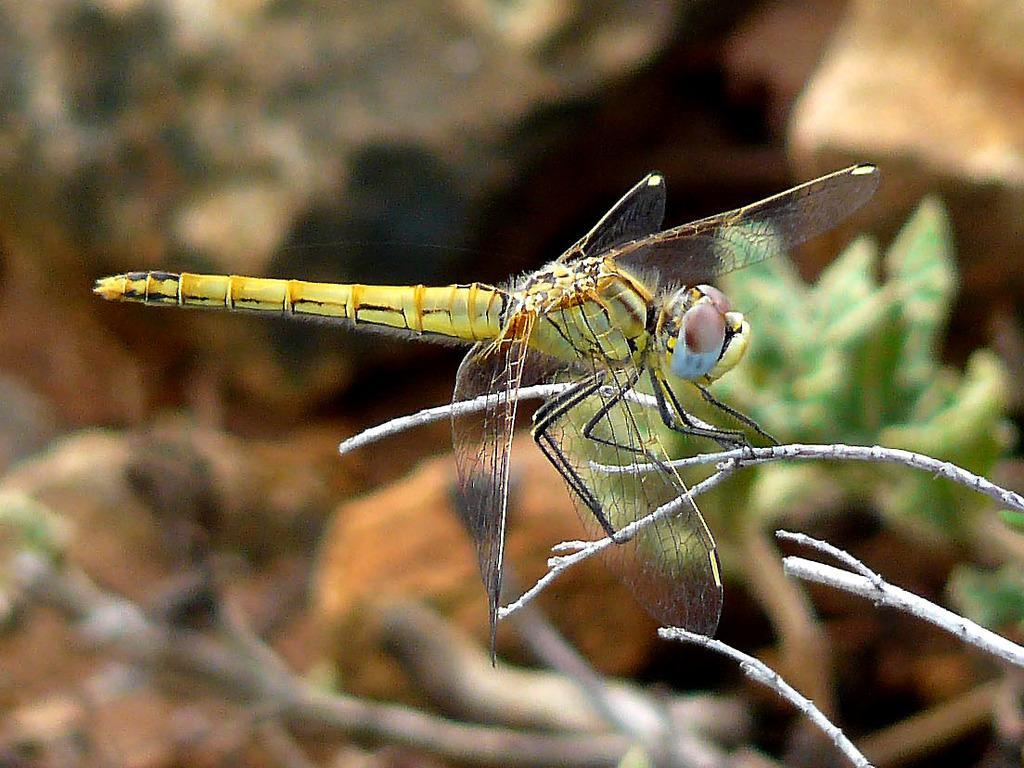Describe this image in one or two sentences. In this image there is an insect on the tree. The background is blurred. 